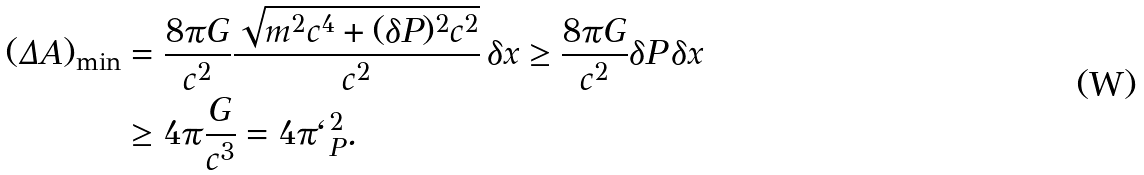Convert formula to latex. <formula><loc_0><loc_0><loc_500><loc_500>( \Delta A ) _ { \min } & = \frac { 8 \pi G } { c ^ { 2 } } \frac { \sqrt { m ^ { 2 } c ^ { 4 } + ( \delta P ) ^ { 2 } c ^ { 2 } } } { c ^ { 2 } } \, \delta x \geq \frac { 8 \pi G } { c ^ { 2 } } \delta P \, \delta x \\ & \geq 4 \pi \frac { G } { c ^ { 3 } } = 4 \pi \ell _ { P } ^ { 2 } .</formula> 